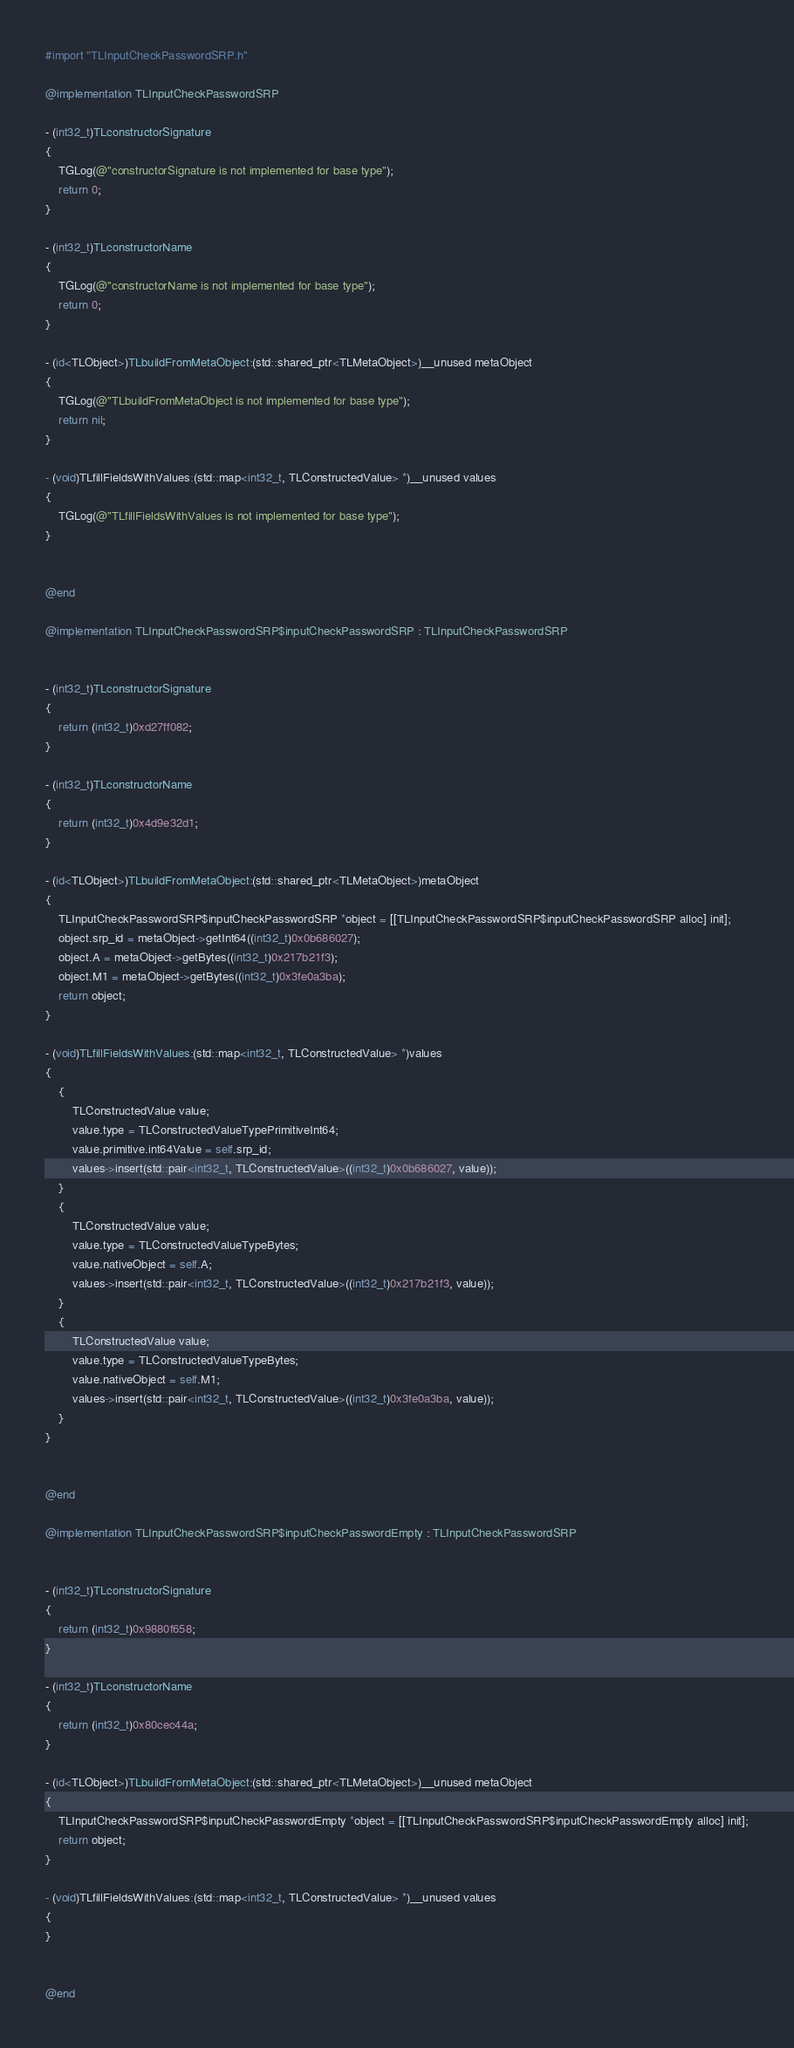Convert code to text. <code><loc_0><loc_0><loc_500><loc_500><_ObjectiveC_>#import "TLInputCheckPasswordSRP.h"

@implementation TLInputCheckPasswordSRP

- (int32_t)TLconstructorSignature
{
    TGLog(@"constructorSignature is not implemented for base type");
    return 0;
}

- (int32_t)TLconstructorName
{
    TGLog(@"constructorName is not implemented for base type");
    return 0;
}

- (id<TLObject>)TLbuildFromMetaObject:(std::shared_ptr<TLMetaObject>)__unused metaObject
{
    TGLog(@"TLbuildFromMetaObject is not implemented for base type");
    return nil;
}

- (void)TLfillFieldsWithValues:(std::map<int32_t, TLConstructedValue> *)__unused values
{
    TGLog(@"TLfillFieldsWithValues is not implemented for base type");
}


@end

@implementation TLInputCheckPasswordSRP$inputCheckPasswordSRP : TLInputCheckPasswordSRP


- (int32_t)TLconstructorSignature
{
    return (int32_t)0xd27ff082;
}

- (int32_t)TLconstructorName
{
    return (int32_t)0x4d9e32d1;
}

- (id<TLObject>)TLbuildFromMetaObject:(std::shared_ptr<TLMetaObject>)metaObject
{
    TLInputCheckPasswordSRP$inputCheckPasswordSRP *object = [[TLInputCheckPasswordSRP$inputCheckPasswordSRP alloc] init];
    object.srp_id = metaObject->getInt64((int32_t)0x0b686027);
    object.A = metaObject->getBytes((int32_t)0x217b21f3);
    object.M1 = metaObject->getBytes((int32_t)0x3fe0a3ba);
    return object;
}

- (void)TLfillFieldsWithValues:(std::map<int32_t, TLConstructedValue> *)values
{
    {
        TLConstructedValue value;
        value.type = TLConstructedValueTypePrimitiveInt64;
        value.primitive.int64Value = self.srp_id;
        values->insert(std::pair<int32_t, TLConstructedValue>((int32_t)0x0b686027, value));
    }
    {
        TLConstructedValue value;
        value.type = TLConstructedValueTypeBytes;
        value.nativeObject = self.A;
        values->insert(std::pair<int32_t, TLConstructedValue>((int32_t)0x217b21f3, value));
    }
    {
        TLConstructedValue value;
        value.type = TLConstructedValueTypeBytes;
        value.nativeObject = self.M1;
        values->insert(std::pair<int32_t, TLConstructedValue>((int32_t)0x3fe0a3ba, value));
    }
}


@end

@implementation TLInputCheckPasswordSRP$inputCheckPasswordEmpty : TLInputCheckPasswordSRP


- (int32_t)TLconstructorSignature
{
    return (int32_t)0x9880f658;
}

- (int32_t)TLconstructorName
{
    return (int32_t)0x80cec44a;
}

- (id<TLObject>)TLbuildFromMetaObject:(std::shared_ptr<TLMetaObject>)__unused metaObject
{
    TLInputCheckPasswordSRP$inputCheckPasswordEmpty *object = [[TLInputCheckPasswordSRP$inputCheckPasswordEmpty alloc] init];
    return object;
}

- (void)TLfillFieldsWithValues:(std::map<int32_t, TLConstructedValue> *)__unused values
{
}


@end

</code> 